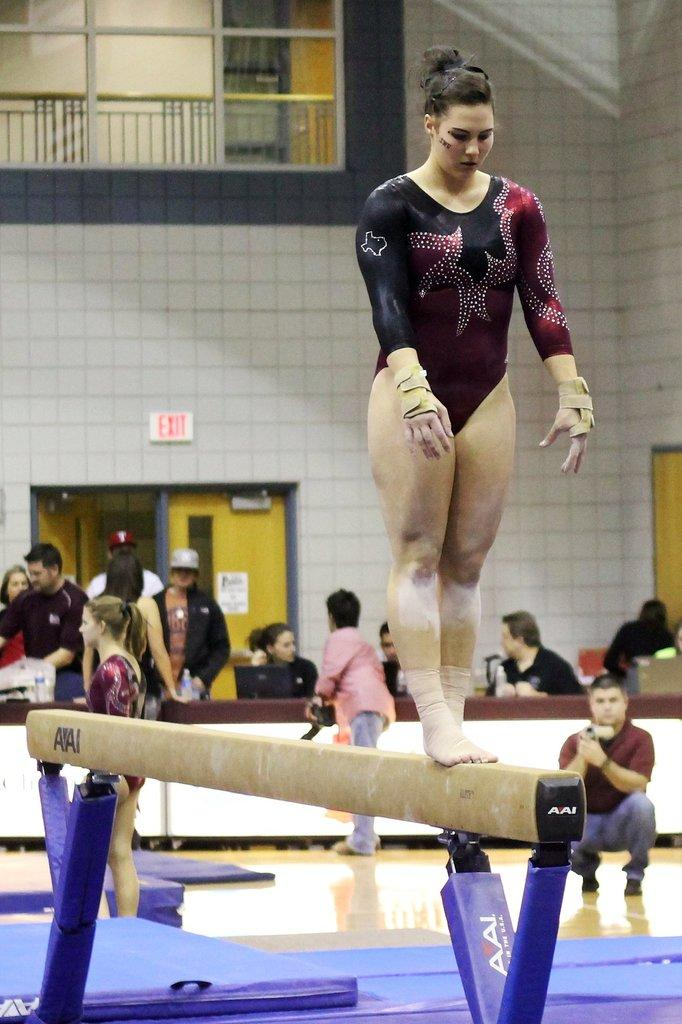What is the woman in the image doing? The woman is standing on a parallel bar in the image. Can you describe the background of the image? In the background of the image, there is a person, fencing, mats, a door, a wall, and windows. What type of surface might the woman be using for support? The parallel bar might be providing support for the woman. What might the mats in the background be used for? The mats in the background might be used for cushioning or safety during physical activities. How many rabbits can be seen hopping around in the image? There are no rabbits present in the image. What type of lizards are crawling on the wall in the image? There are no lizards present in the image. 